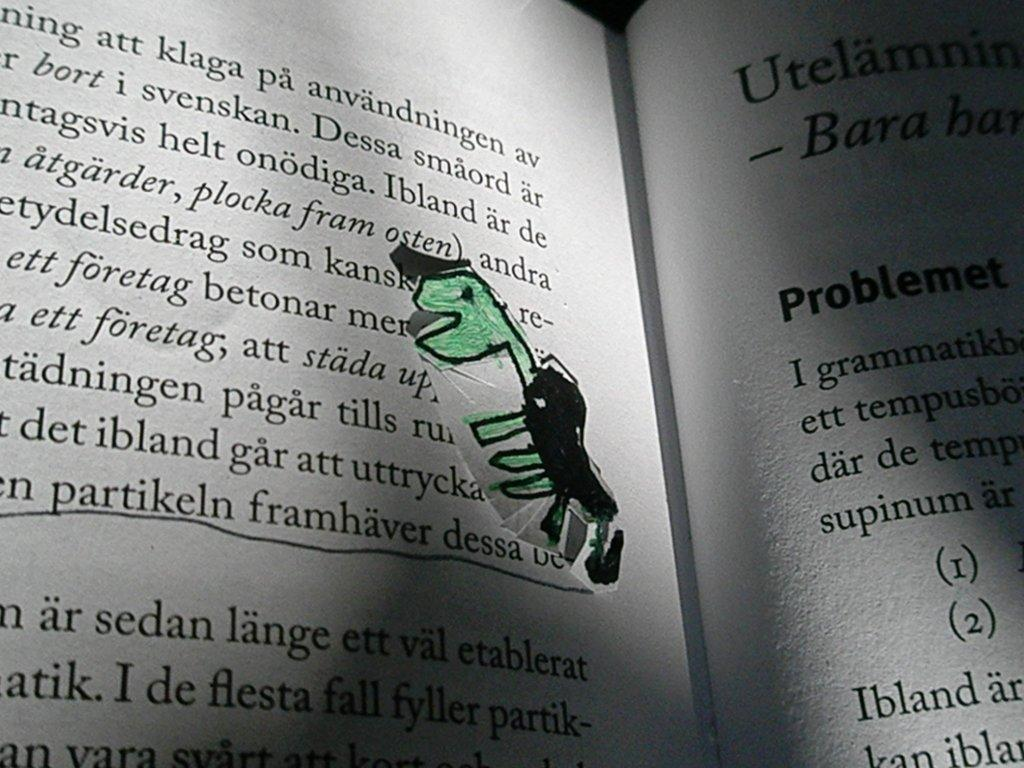Provide a one-sentence caption for the provided image. A poorly drawn dinosaur on a page of the book eating the word betonar. 